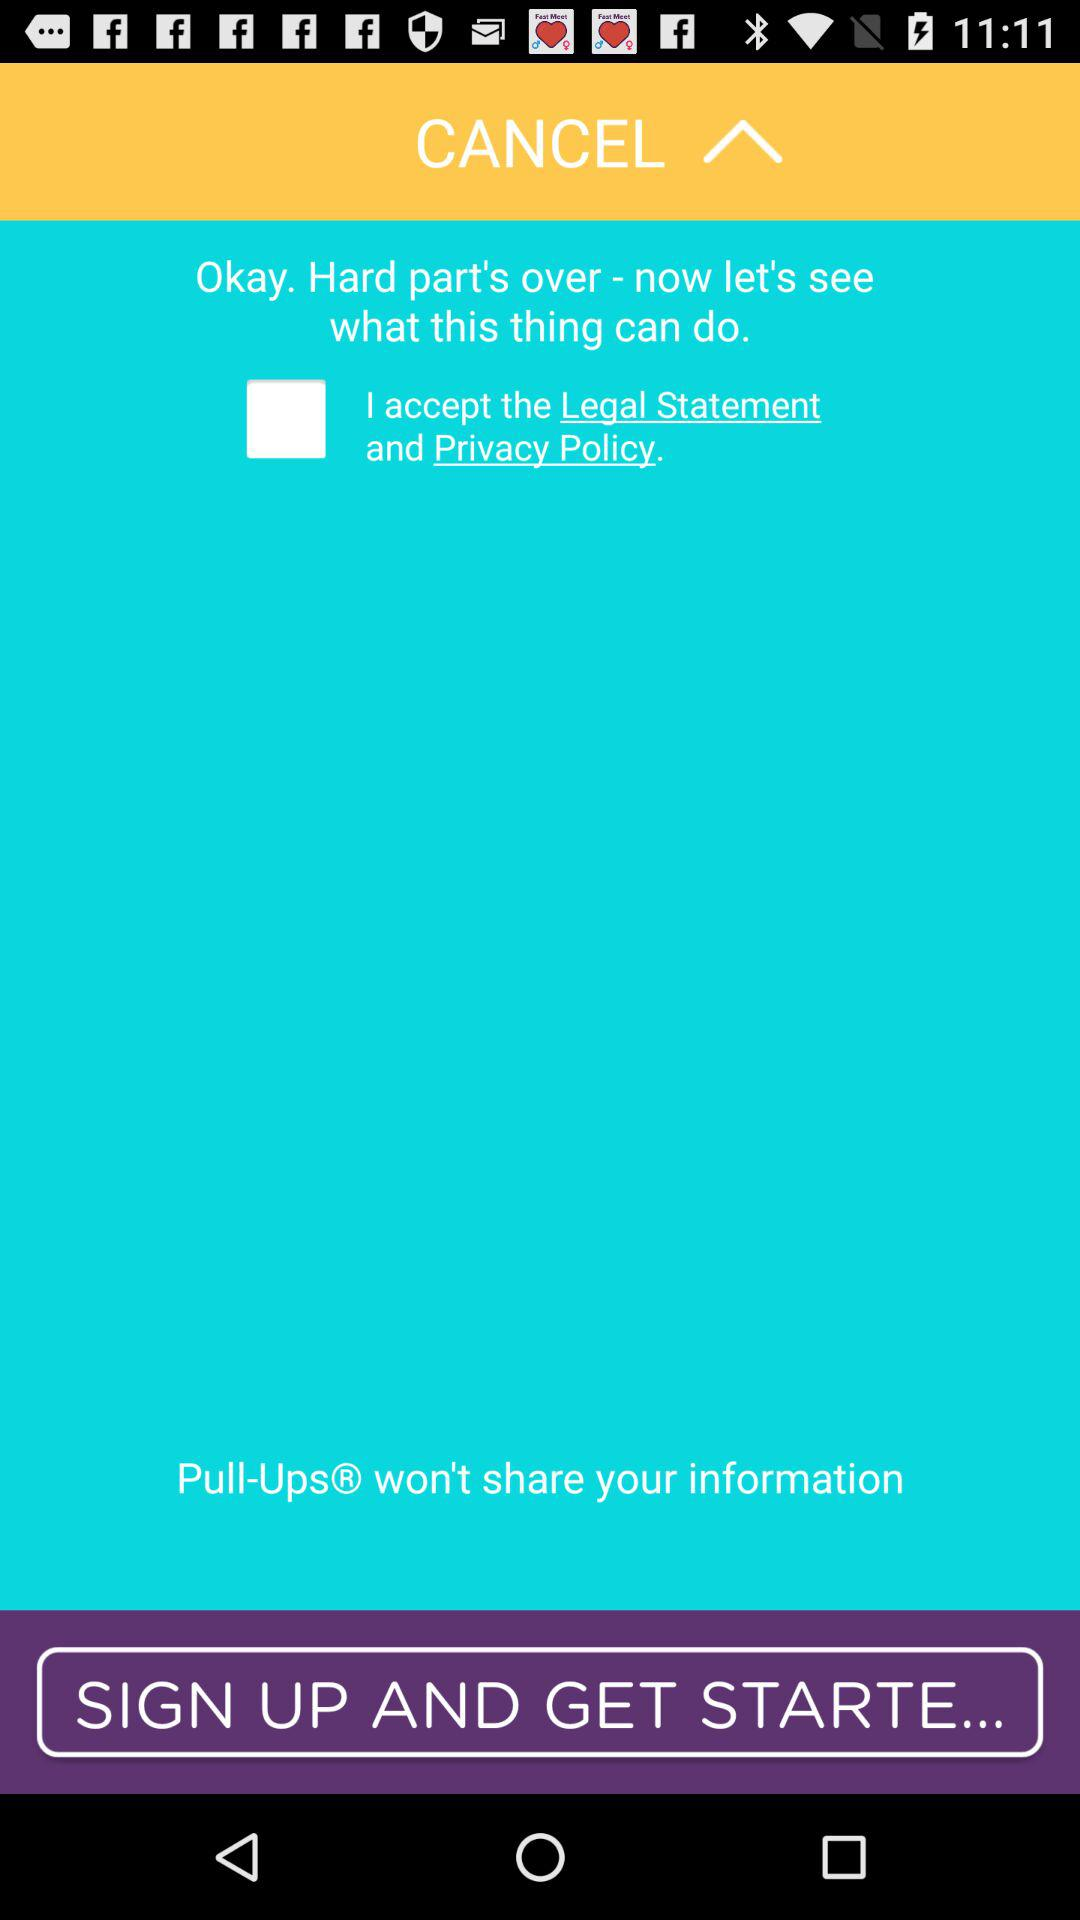What is the status of the option that includes agreement to the “Legal Statement and Privacy Policy”? The status is "off". 